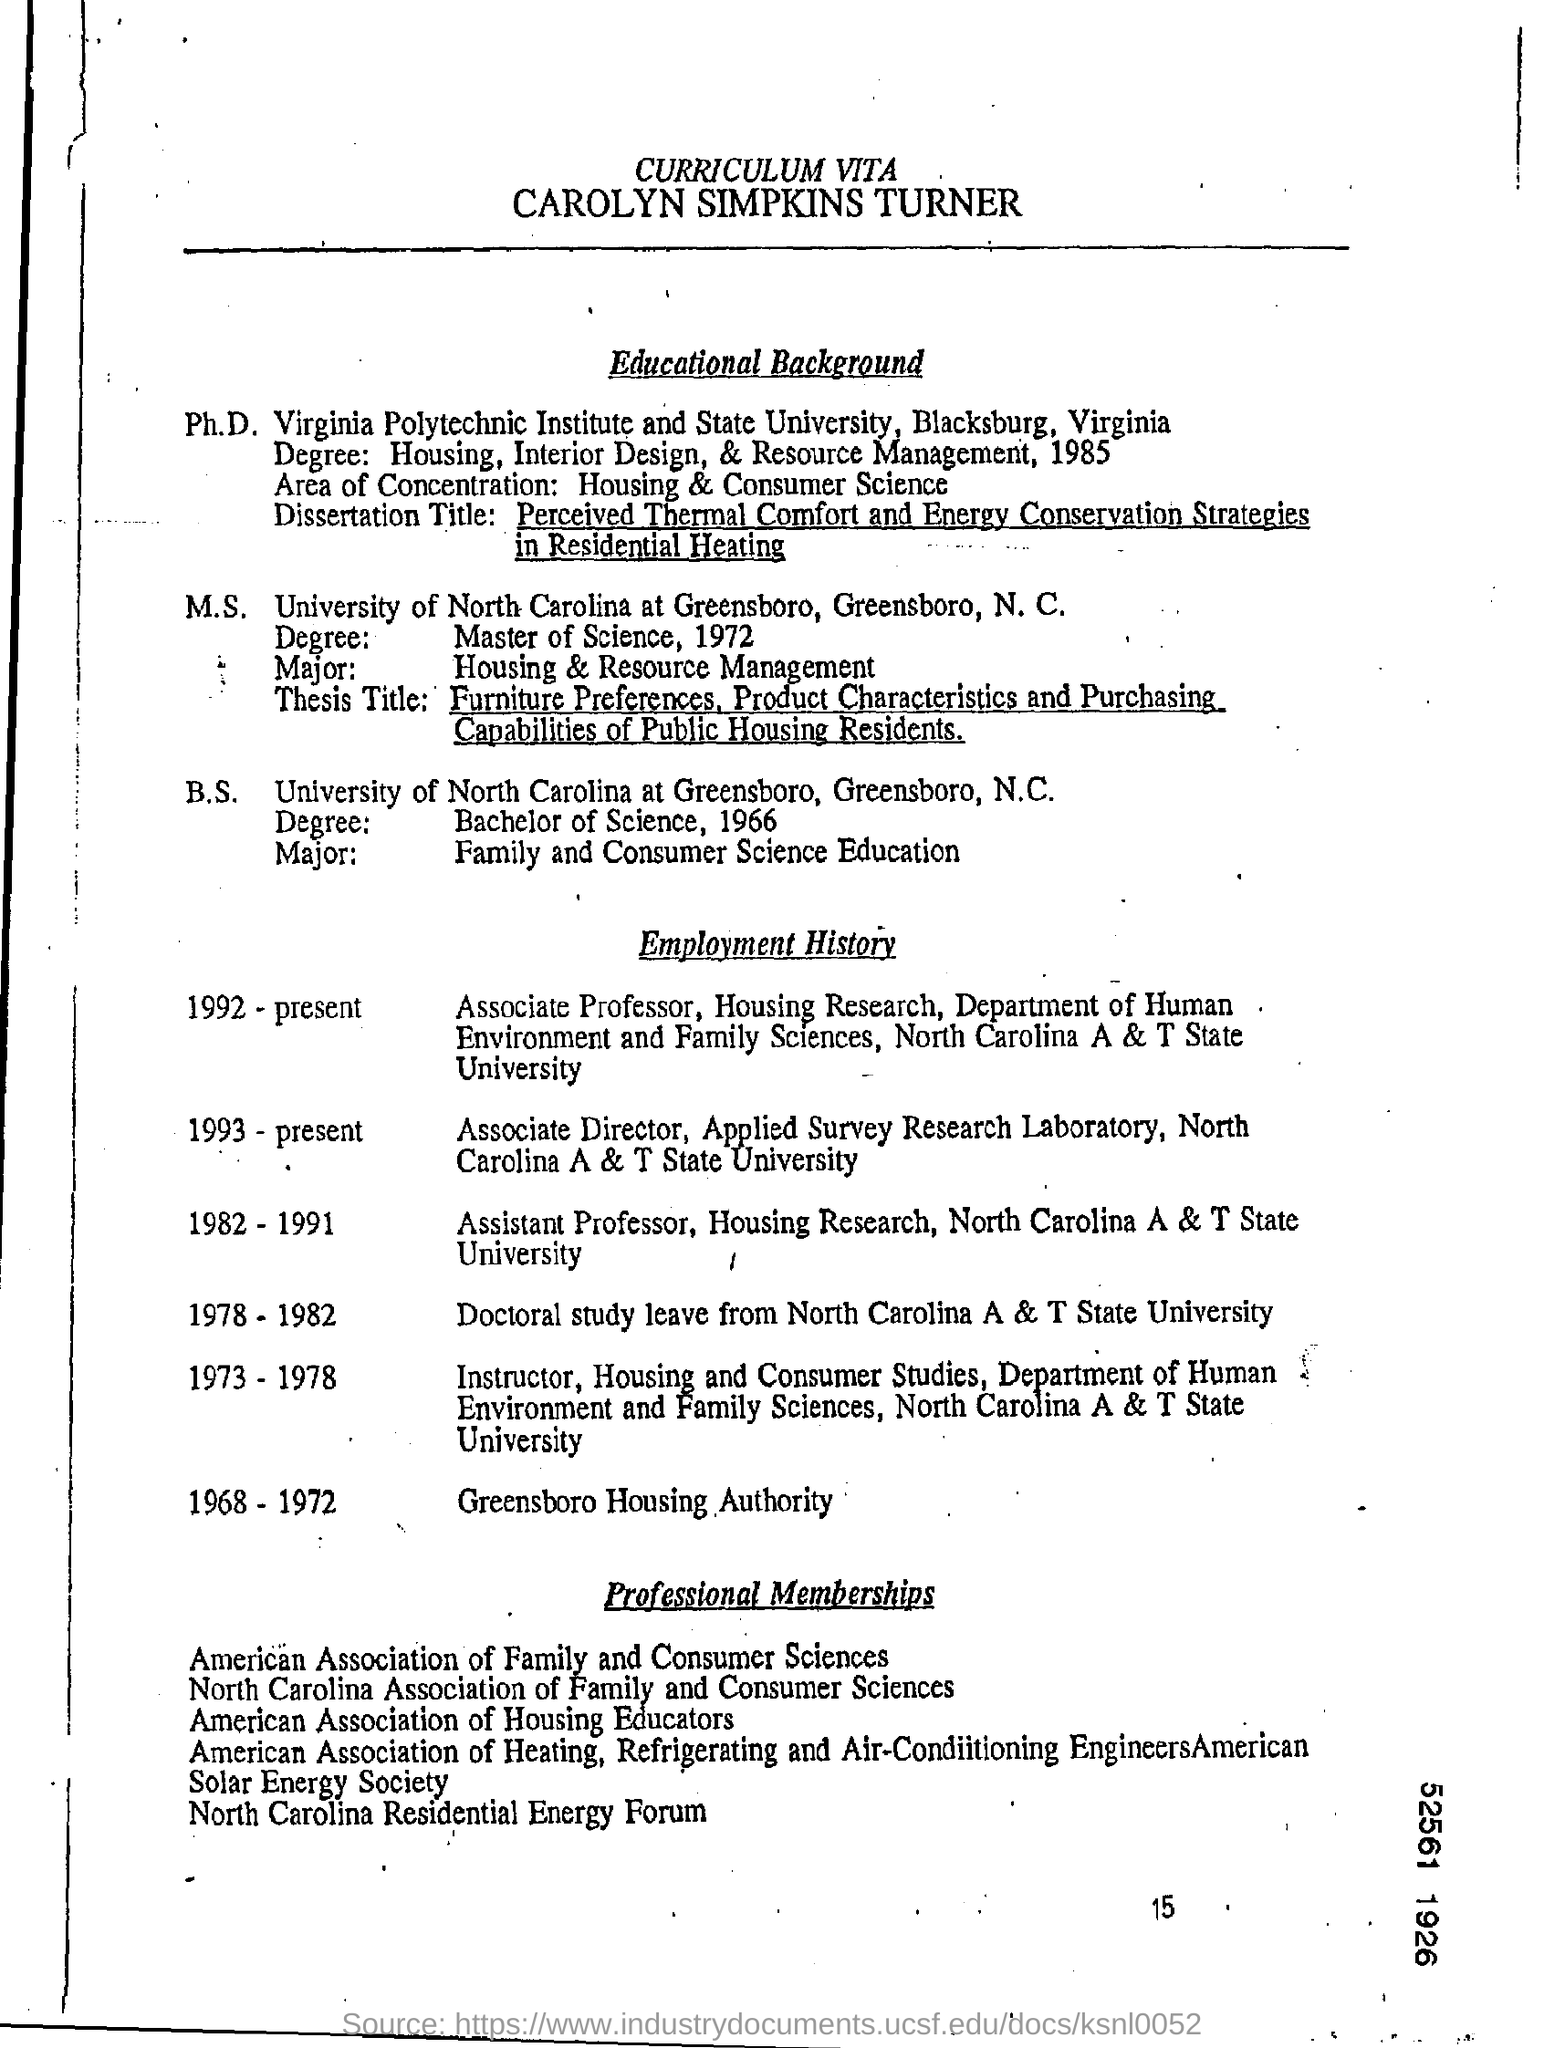WHOSE CURRICULUM VITAE IS IT?
Provide a short and direct response. CAROLYN SIMPKINS TURNER. FROM WHICH UNIVERSITY DID CAROLYN  GRADUATE M.S.?
Provide a succinct answer. UNIVERSITY OF NORTH CAROLINA AT GREENSBORO. WHAT IS THE JOB ROLE OF CAROLYN FROM 1952-PRESENT?
Give a very brief answer. ASSOCIATE PROFESSOR. IN WHICH YEAR DID CAROLYN TAKE DOCTORAL STUDY LEAVE?
Offer a terse response. 1978-1982. 